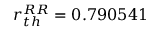Convert formula to latex. <formula><loc_0><loc_0><loc_500><loc_500>r _ { t h } ^ { R R } = 0 . 7 9 0 5 4 1</formula> 